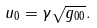Convert formula to latex. <formula><loc_0><loc_0><loc_500><loc_500>u _ { 0 } = \gamma \sqrt { g _ { 0 0 } } .</formula> 